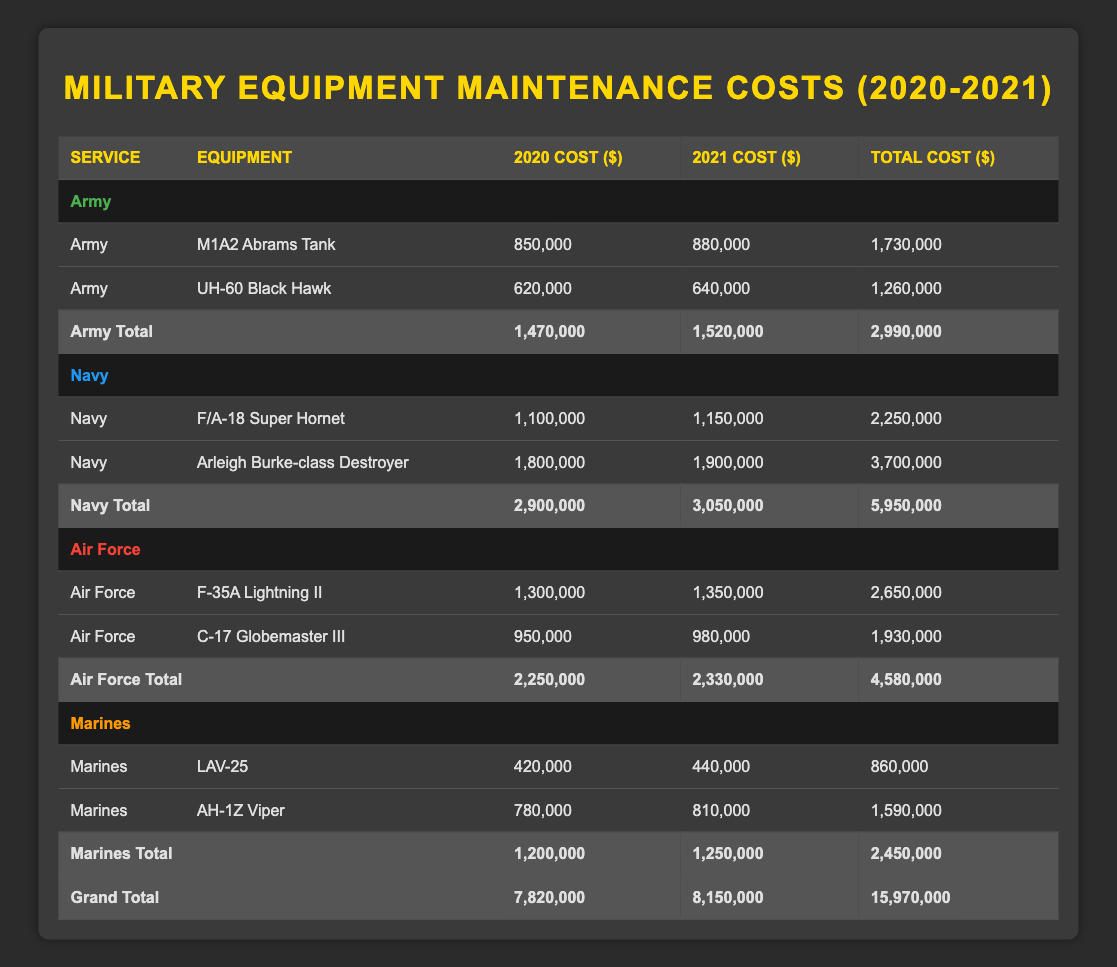What is the total maintenance cost for the Army in 2020? From the table, the costs for the Army in 2020 are 850,000 for the M1A2 Abrams Tank and 620,000 for the UH-60 Black Hawk. Summing these values gives 850,000 + 620,000 = 1,470,000.
Answer: 1,470,000 What is the maintenance cost of the Arleigh Burke-class Destroyer in 2021? The table shows the maintenance cost for the Arleigh Burke-class Destroyer in 2021 as 1,900,000.
Answer: 1,900,000 Which service branch had the highest total maintenance cost over the two years? The total costs over both years for each service are: Army: 2,990,000, Navy: 5,950,000, Air Force: 4,580,000, Marines: 2,450,000. The highest total is for the Navy at 5,950,000.
Answer: Navy What is the combined maintenance cost for the F-35A Lightning II over both years? The F-35A Lightning II cost is 1,300,000 in 2020 and 1,350,000 in 2021. Adding these gives: 1,300,000 + 1,350,000 = 2,650,000.
Answer: 2,650,000 Did the total maintenance cost for the Marines increase from 2020 to 2021? In 2020, the Marines' costs were 1,200,000 and in 2021 it increased to 1,250,000. Since 1,250,000 > 1,200,000, the total cost increased.
Answer: Yes What is the average maintenance cost for both years for the Air Force? The total for the Air Force is 2,250,000 for 2020 and 2,330,000 for 2021, which sums to 4,580,000 over two years. Dividing by the number of years (2) gives an average of 4,580,000 / 2 = 2,290,000.
Answer: 2,290,000 How much less did the Marines spend on maintenance in 2020 compared to the Navy? The Marines spent a total of 1,200,000 in 2020 and the Navy spent 2,900,000. The difference is 2,900,000 - 1,200,000 = 1,700,000, so the Marines spent 1,700,000 less than the Navy.
Answer: 1,700,000 What equipment had the highest single-year maintenance cost in 2021? In 2021, the costs are: F/A-18 Super Hornet: 1,150,000, Arleigh Burke-class Destroyer: 1,900,000, F-35A Lightning II: 1,350,000, C-17 Globemaster III: 980,000, LAV-25: 440,000, AH-1Z Viper: 810,000. The highest is the Arleigh Burke-class Destroyer at 1,900,000.
Answer: Arleigh Burke-class Destroyer What is the total maintenance cost across all branches for 2021? The costs for 2021 are: Army 1,520,000, Navy 3,050,000, Air Force 2,330,000, and Marines 1,250,000. Summing these gives 1,520,000 + 3,050,000 + 2,330,000 + 1,250,000 = 8,150,000.
Answer: 8,150,000 